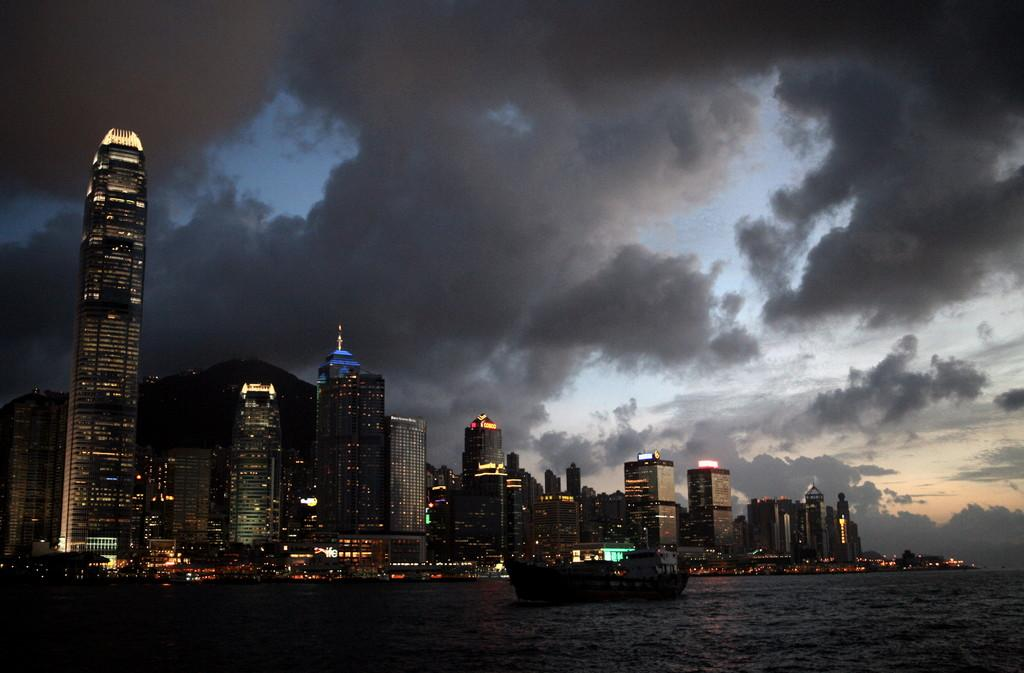What type of structures are present in the image? There are buildings with windows in the image. What can be seen inside the buildings? Lights are visible in the image, which suggests that the buildings are illuminated. What is the natural element present in the image? There is water visible in the image. What type of vehicles are present in the water? There are boats in the image. What is visible above the buildings and water? The sky is visible in the image. What is the weather condition in the image? Clouds are present in the sky, which suggests that it might be partly cloudy. Where is the clover growing in the image? There is no clover present in the image. What type of rat can be seen swimming in the water in the image? There are no rats present in the image; it features buildings, lights, water, boats, and clouds. 